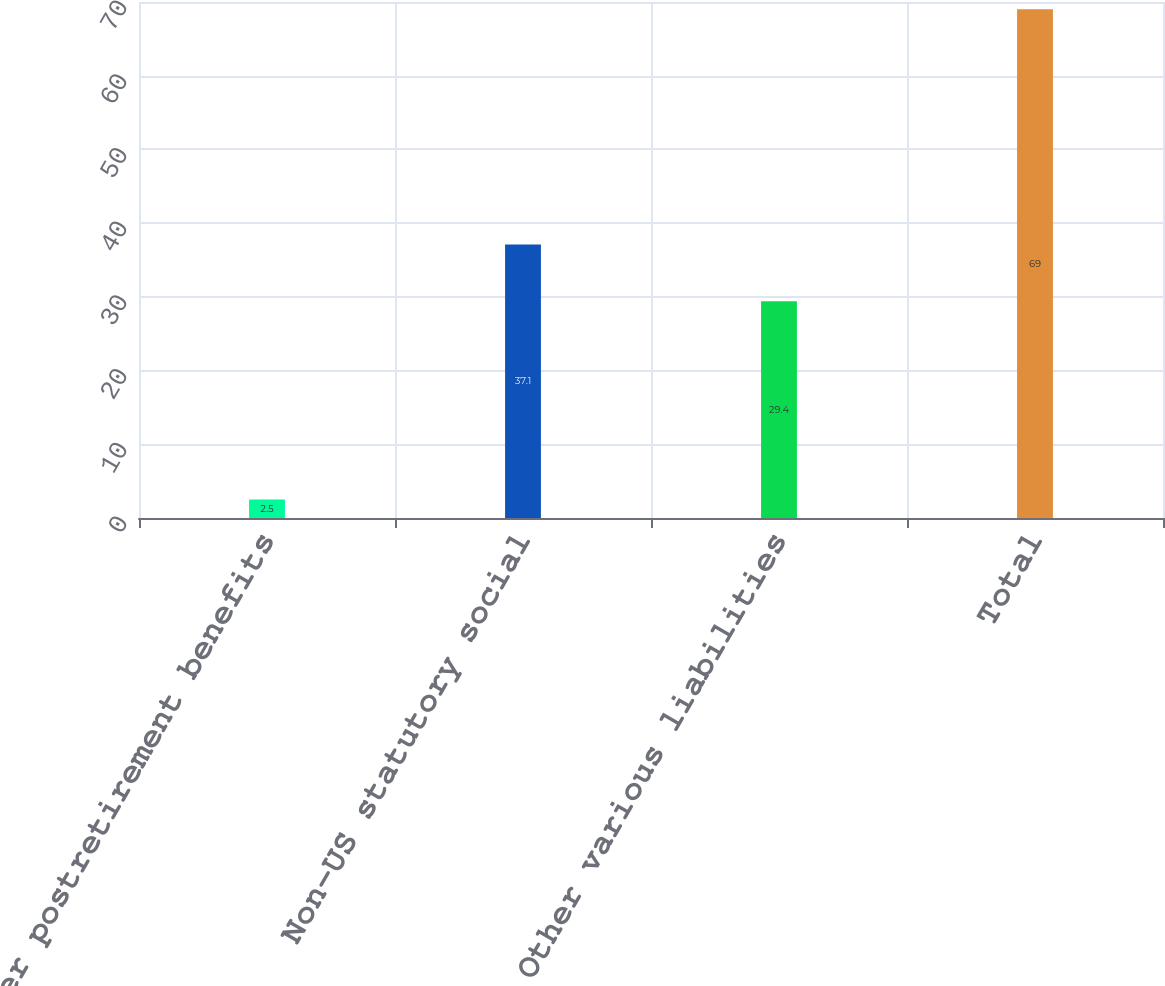Convert chart to OTSL. <chart><loc_0><loc_0><loc_500><loc_500><bar_chart><fcel>Other postretirement benefits<fcel>Non-US statutory social<fcel>Other various liabilities<fcel>Total<nl><fcel>2.5<fcel>37.1<fcel>29.4<fcel>69<nl></chart> 